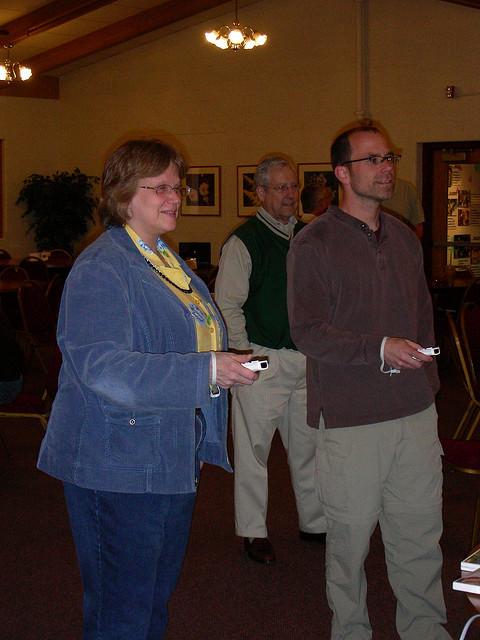How many people are playing the game?
Answer briefly. 2. Where is this event taking place?
Answer briefly. Home. Are these people playing a video game in a bar?
Concise answer only. Yes. How many people are in the image?
Write a very short answer. 3. What is the man holding in his right hand?
Quick response, please. Wii controller. Where are these people at?
Write a very short answer. House. What color are the walls?
Short answer required. White. Is the woman in the blue shirt wearing sunglasses?
Write a very short answer. No. Is the woman in focus?
Short answer required. Yes. Is this an airport?
Quick response, please. No. What gaming system are the people playing?
Give a very brief answer. Wii. What kind of celebration is this?
Concise answer only. Birthday. 